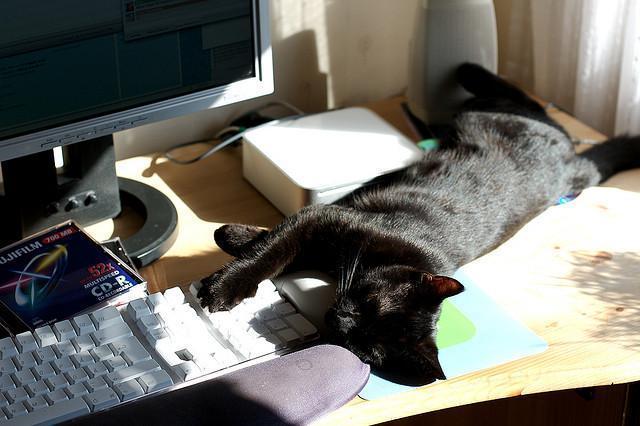How many people are between the two orange buses in the image?
Give a very brief answer. 0. 